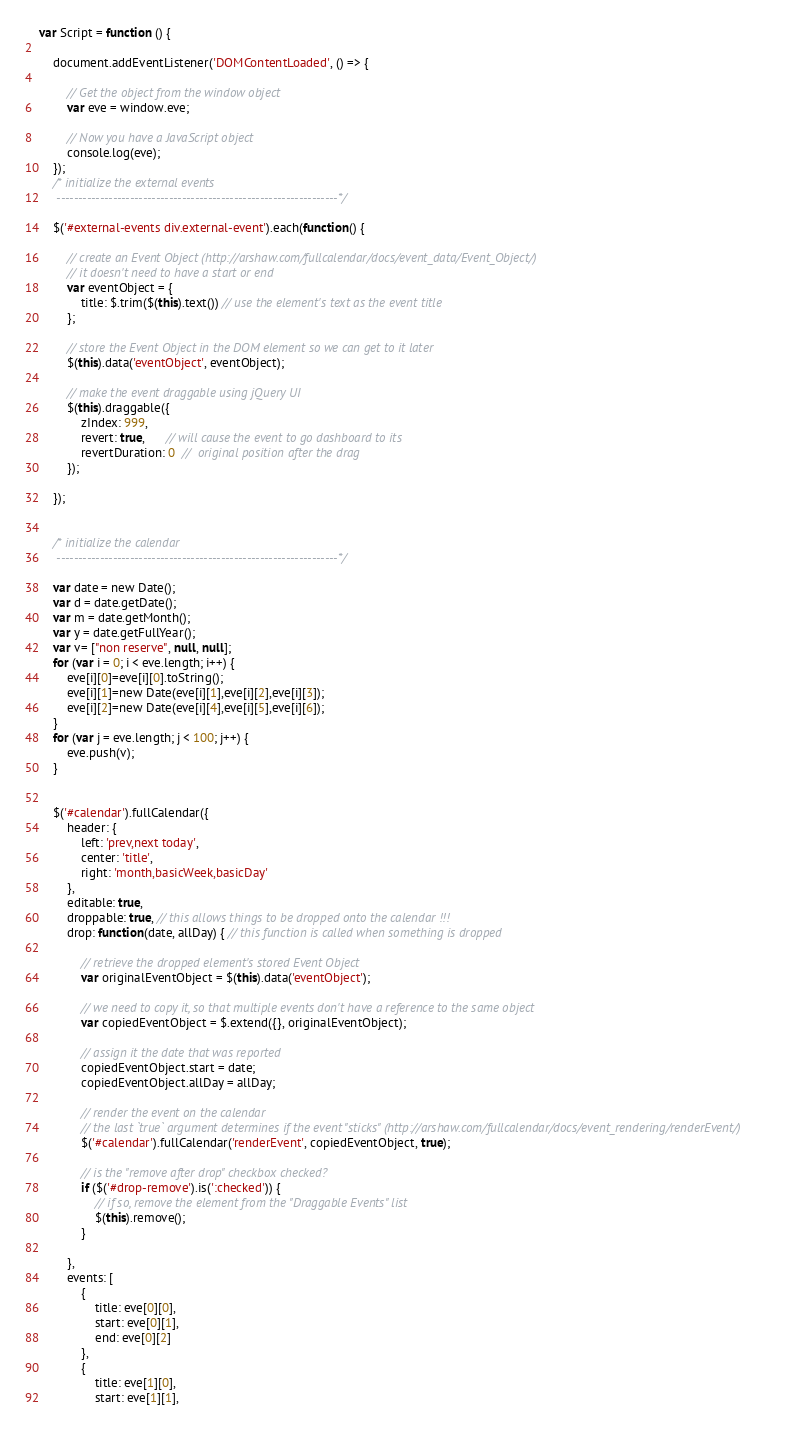<code> <loc_0><loc_0><loc_500><loc_500><_JavaScript_>var Script = function () {

    document.addEventListener('DOMContentLoaded', () => {

        // Get the object from the window object
        var eve = window.eve;

        // Now you have a JavaScript object
        console.log(eve);
    });
    /* initialize the external events
     -----------------------------------------------------------------*/

    $('#external-events div.external-event').each(function() {

        // create an Event Object (http://arshaw.com/fullcalendar/docs/event_data/Event_Object/)
        // it doesn't need to have a start or end
        var eventObject = {
            title: $.trim($(this).text()) // use the element's text as the event title
        };

        // store the Event Object in the DOM element so we can get to it later
        $(this).data('eventObject', eventObject);

        // make the event draggable using jQuery UI
        $(this).draggable({
            zIndex: 999,
            revert: true,      // will cause the event to go dashboard to its
            revertDuration: 0  //  original position after the drag
        });

    });


    /* initialize the calendar
     -----------------------------------------------------------------*/

    var date = new Date();
    var d = date.getDate();
    var m = date.getMonth();
    var y = date.getFullYear();
    var v= ["non reserve", null, null];
    for (var i = 0; i < eve.length; i++) {
        eve[i][0]=eve[i][0].toString();
        eve[i][1]=new Date(eve[i][1],eve[i][2],eve[i][3]);
        eve[i][2]=new Date(eve[i][4],eve[i][5],eve[i][6]);
    }
    for (var j = eve.length; j < 100; j++) {
        eve.push(v);
    }


    $('#calendar').fullCalendar({
        header: {
            left: 'prev,next today',
            center: 'title',
            right: 'month,basicWeek,basicDay'
        },
        editable: true,
        droppable: true, // this allows things to be dropped onto the calendar !!!
        drop: function(date, allDay) { // this function is called when something is dropped

            // retrieve the dropped element's stored Event Object
            var originalEventObject = $(this).data('eventObject');

            // we need to copy it, so that multiple events don't have a reference to the same object
            var copiedEventObject = $.extend({}, originalEventObject);

            // assign it the date that was reported
            copiedEventObject.start = date;
            copiedEventObject.allDay = allDay;

            // render the event on the calendar
            // the last `true` argument determines if the event "sticks" (http://arshaw.com/fullcalendar/docs/event_rendering/renderEvent/)
            $('#calendar').fullCalendar('renderEvent', copiedEventObject, true);

            // is the "remove after drop" checkbox checked?
            if ($('#drop-remove').is(':checked')) {
                // if so, remove the element from the "Draggable Events" list
                $(this).remove();
            }

        },
        events: [
            {
                title: eve[0][0],
                start: eve[0][1],
                end: eve[0][2]
            },
            {
                title: eve[1][0],
                start: eve[1][1],</code> 